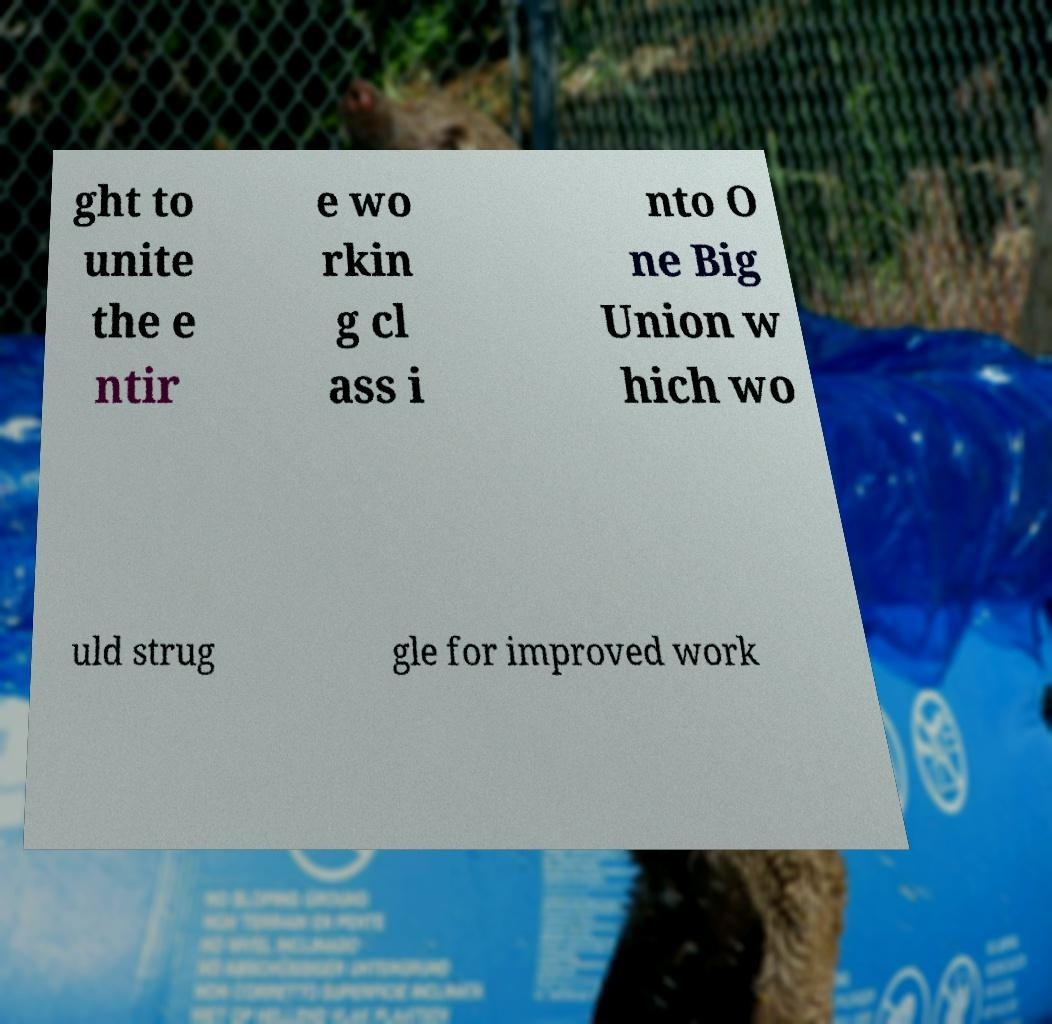I need the written content from this picture converted into text. Can you do that? ght to unite the e ntir e wo rkin g cl ass i nto O ne Big Union w hich wo uld strug gle for improved work 